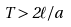<formula> <loc_0><loc_0><loc_500><loc_500>T > 2 \ell / a</formula> 